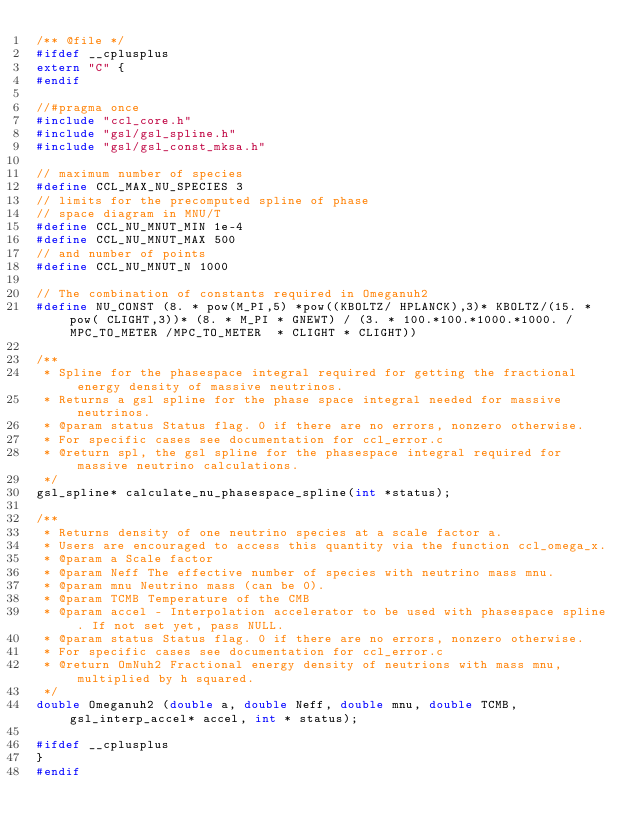<code> <loc_0><loc_0><loc_500><loc_500><_C_>/** @file */
#ifdef __cplusplus
extern "C" {
#endif

//#pragma once
#include "ccl_core.h"
#include "gsl/gsl_spline.h"
#include "gsl/gsl_const_mksa.h"

// maximum number of species
#define CCL_MAX_NU_SPECIES 3
// limits for the precomputed spline of phase
// space diagram in MNU/T
#define CCL_NU_MNUT_MIN 1e-4
#define CCL_NU_MNUT_MAX 500
// and number of points
#define CCL_NU_MNUT_N 1000

// The combination of constants required in Omeganuh2
#define NU_CONST (8. * pow(M_PI,5) *pow((KBOLTZ/ HPLANCK),3)* KBOLTZ/(15. *pow( CLIGHT,3))* (8. * M_PI * GNEWT) / (3. * 100.*100.*1000.*1000. /MPC_TO_METER /MPC_TO_METER  * CLIGHT * CLIGHT))

/**
 * Spline for the phasespace integral required for getting the fractional energy density of massive neutrinos.
 * Returns a gsl spline for the phase space integral needed for massive neutrinos.
 * @param status Status flag. 0 if there are no errors, nonzero otherwise.
 * For specific cases see documentation for ccl_error.c
 * @return spl, the gsl spline for the phasespace integral required for massive neutrino calculations.
 */
gsl_spline* calculate_nu_phasespace_spline(int *status);

/** 
 * Returns density of one neutrino species at a scale factor a. 
 * Users are encouraged to access this quantity via the function ccl_omega_x.
 * @param a Scale factor
 * @param Neff The effective number of species with neutrino mass mnu.
 * @param mnu Neutrino mass (can be 0).
 * @param TCMB Temperature of the CMB
 * @param accel - Interpolation accelerator to be used with phasespace spline. If not set yet, pass NULL.
 * @param status Status flag. 0 if there are no errors, nonzero otherwise.
 * For specific cases see documentation for ccl_error.c
 * @return OmNuh2 Fractional energy density of neutrions with mass mnu, multiplied by h squared. 
 */
double Omeganuh2 (double a, double Neff, double mnu, double TCMB, gsl_interp_accel* accel, int * status);

#ifdef __cplusplus
}
#endif
</code> 